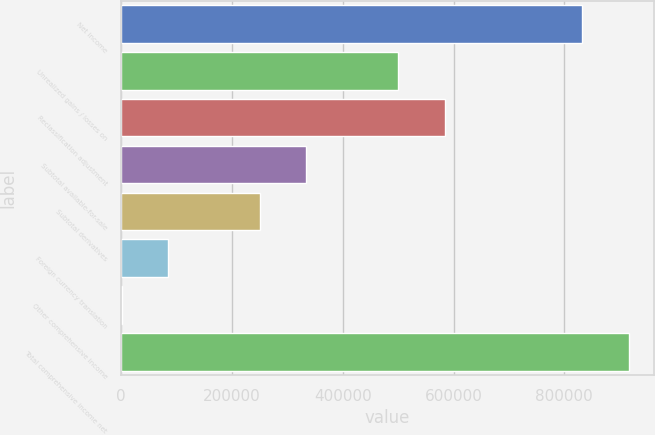Convert chart to OTSL. <chart><loc_0><loc_0><loc_500><loc_500><bar_chart><fcel>Net income<fcel>Unrealized gains / losses on<fcel>Reclassification adjustment<fcel>Subtotal available-for-sale<fcel>Subtotal derivatives<fcel>Foreign currency translation<fcel>Other comprehensive income<fcel>Total comprehensive income net<nl><fcel>832775<fcel>500427<fcel>583704<fcel>333872<fcel>250594<fcel>84039.5<fcel>762<fcel>916052<nl></chart> 